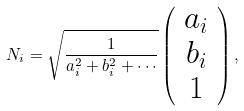Convert formula to latex. <formula><loc_0><loc_0><loc_500><loc_500>N _ { i } = \sqrt { \frac { 1 } { a _ { i } ^ { 2 } + b _ { i } ^ { 2 } + \cdots } } \left ( \begin{array} { c } a _ { i } \\ b _ { i } \\ 1 \end{array} \right ) ,</formula> 